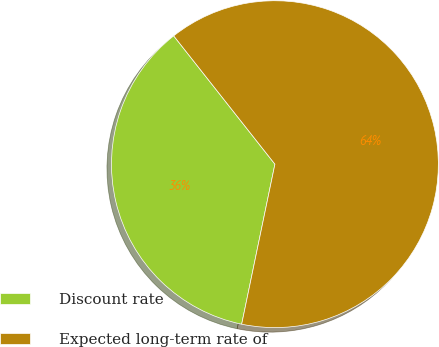Convert chart to OTSL. <chart><loc_0><loc_0><loc_500><loc_500><pie_chart><fcel>Discount rate<fcel>Expected long-term rate of<nl><fcel>36.11%<fcel>63.89%<nl></chart> 